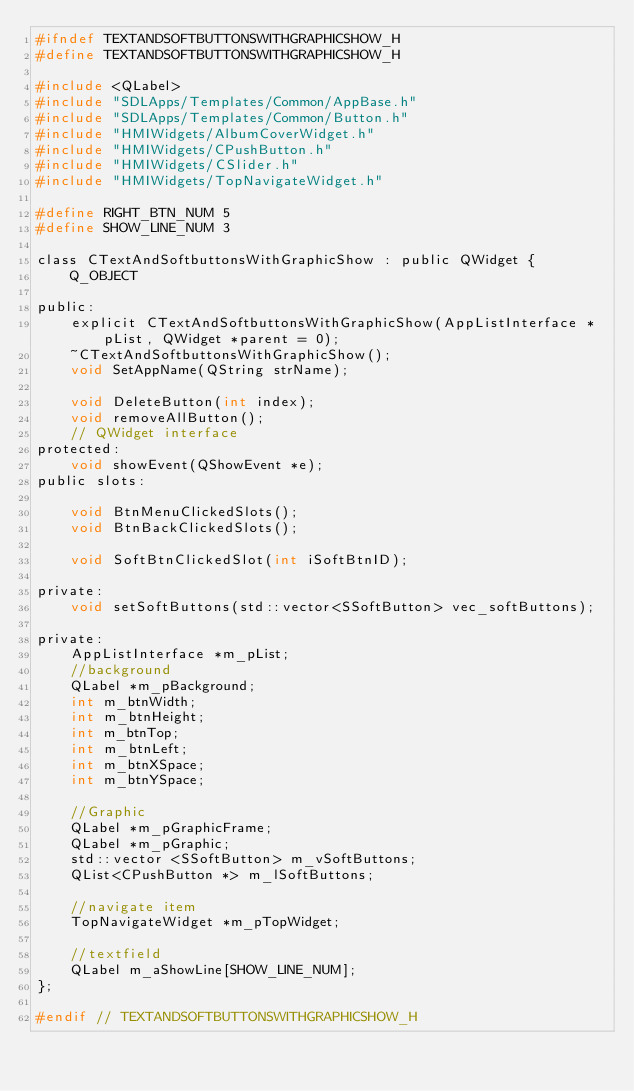<code> <loc_0><loc_0><loc_500><loc_500><_C_>#ifndef TEXTANDSOFTBUTTONSWITHGRAPHICSHOW_H
#define TEXTANDSOFTBUTTONSWITHGRAPHICSHOW_H

#include <QLabel>
#include "SDLApps/Templates/Common/AppBase.h"
#include "SDLApps/Templates/Common/Button.h"
#include "HMIWidgets/AlbumCoverWidget.h"
#include "HMIWidgets/CPushButton.h"
#include "HMIWidgets/CSlider.h"
#include "HMIWidgets/TopNavigateWidget.h"

#define RIGHT_BTN_NUM 5
#define SHOW_LINE_NUM 3

class CTextAndSoftbuttonsWithGraphicShow : public QWidget {
    Q_OBJECT

public:
    explicit CTextAndSoftbuttonsWithGraphicShow(AppListInterface *pList, QWidget *parent = 0);
    ~CTextAndSoftbuttonsWithGraphicShow();
    void SetAppName(QString strName);

    void DeleteButton(int index);
    void removeAllButton();
    // QWidget interface
protected:
    void showEvent(QShowEvent *e);
public slots:

    void BtnMenuClickedSlots();
    void BtnBackClickedSlots();

    void SoftBtnClickedSlot(int iSoftBtnID);

private:
    void setSoftButtons(std::vector<SSoftButton> vec_softButtons);

private:
    AppListInterface *m_pList;
    //background
    QLabel *m_pBackground;
    int m_btnWidth;
    int m_btnHeight;
    int m_btnTop;
    int m_btnLeft;
    int m_btnXSpace;
    int m_btnYSpace;

    //Graphic
    QLabel *m_pGraphicFrame;
    QLabel *m_pGraphic;
    std::vector <SSoftButton> m_vSoftButtons;
    QList<CPushButton *> m_lSoftButtons;

    //navigate item
    TopNavigateWidget *m_pTopWidget;

    //textfield
    QLabel m_aShowLine[SHOW_LINE_NUM];
};

#endif // TEXTANDSOFTBUTTONSWITHGRAPHICSHOW_H
</code> 